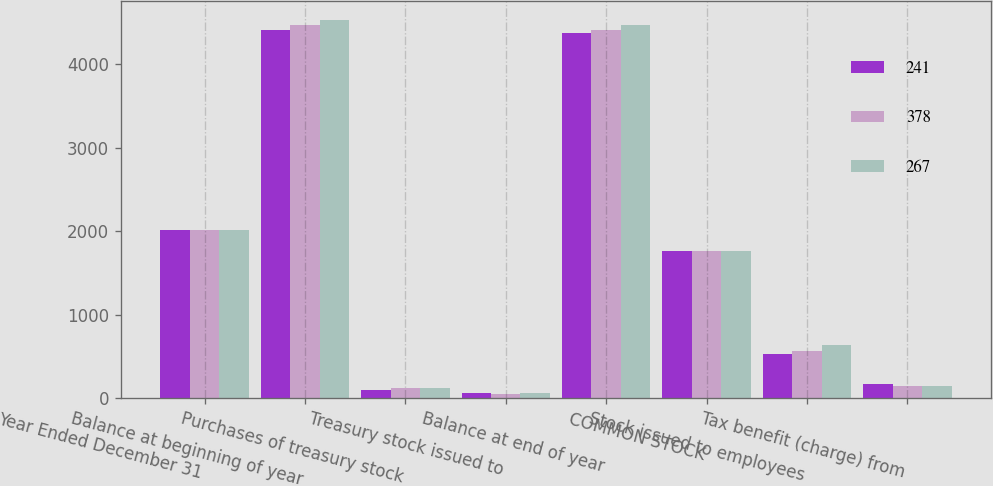Convert chart. <chart><loc_0><loc_0><loc_500><loc_500><stacked_bar_chart><ecel><fcel>Year Ended December 31<fcel>Balance at beginning of year<fcel>Purchases of treasury stock<fcel>Treasury stock issued to<fcel>Balance at end of year<fcel>COMMON STOCK<fcel>Stock issued to employees<fcel>Tax benefit (charge) from<nl><fcel>241<fcel>2014<fcel>4402<fcel>98<fcel>62<fcel>4366<fcel>1760<fcel>526<fcel>169<nl><fcel>378<fcel>2013<fcel>4469<fcel>121<fcel>54<fcel>4402<fcel>1760<fcel>569<fcel>144<nl><fcel>267<fcel>2012<fcel>4526<fcel>121<fcel>64<fcel>4469<fcel>1760<fcel>640<fcel>144<nl></chart> 